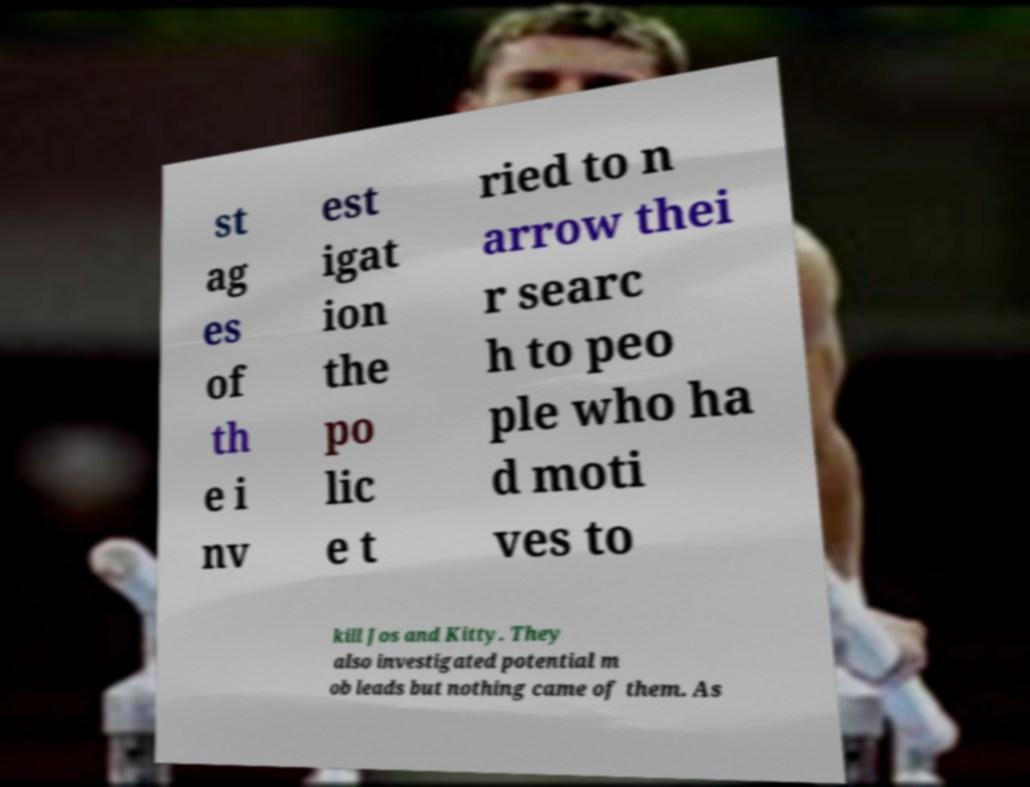Can you read and provide the text displayed in the image?This photo seems to have some interesting text. Can you extract and type it out for me? st ag es of th e i nv est igat ion the po lic e t ried to n arrow thei r searc h to peo ple who ha d moti ves to kill Jos and Kitty. They also investigated potential m ob leads but nothing came of them. As 